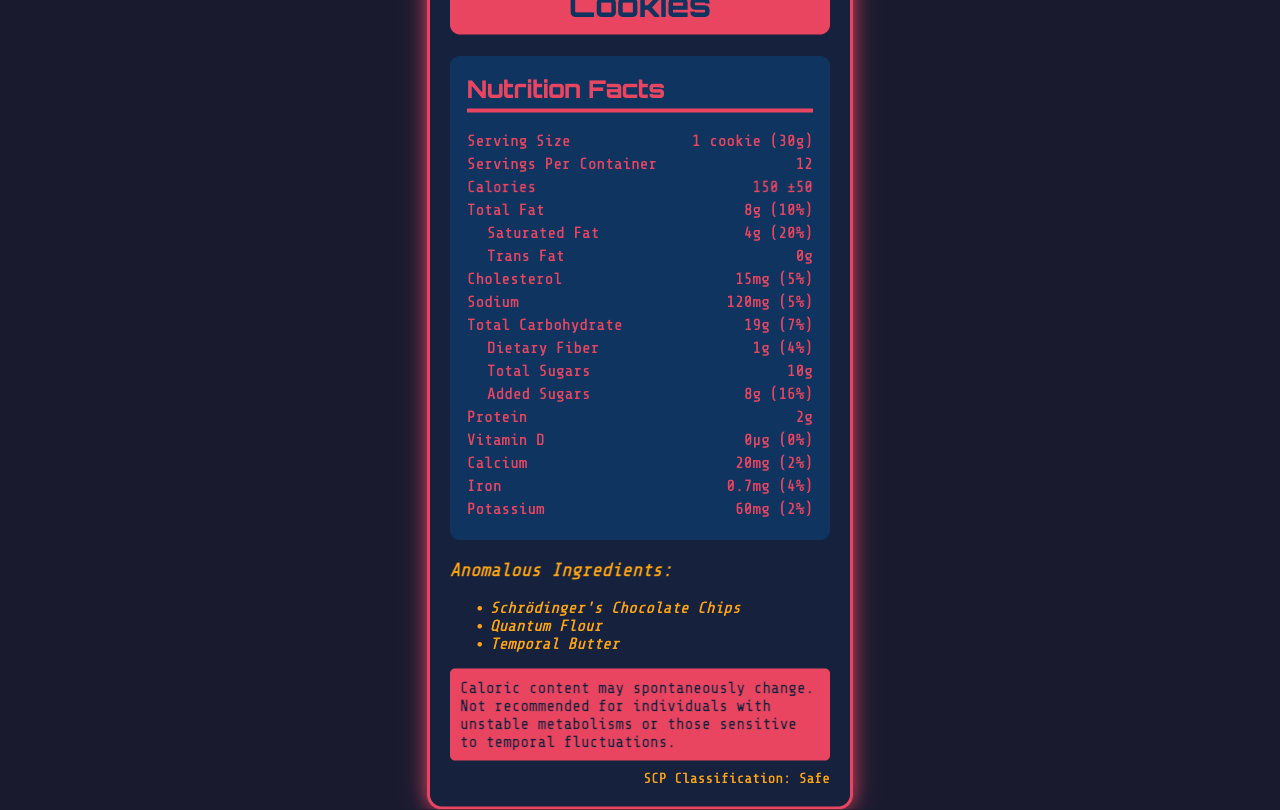What is the base calorie content of a Containment Cookie? The document lists the base calorie content as 150 calories per cookie.
Answer: 150 calories How large is the serving size for Containment Cookies? The serving size is specified as 1 cookie, which weighs 30 grams.
Answer: 1 cookie (30g) What is the daily value percentage for total fat in one Containment Cookie? The document shows that the total fat in one cookie contributes 10% to the daily value.
Answer: 10% Which ingredients are considered anomalous in the Containment Cookies? The document lists Schrödinger's Chocolate Chips, Quantum Flour, and Temporal Butter under anomalous ingredients.
Answer: Schrödinger's Chocolate Chips, Quantum Flour, Temporal Butter What is the SCP classification for Containment Cookies? The SCP classification is labeled as Safe in the document.
Answer: Safe How many milligrams of sodium are in a single Containment Cookie? The sodium content is listed as 120 milligrams per cookie.
Answer: 120 milligrams Which of the following statements is true about the vitamin D content in Containment Cookies? A. There is a high amount of vitamin D. B. The vitamin D content is zero. C. The vitamin D content fluctuates. D. It is not specified. The document specifies that the vitamin D content is 0 micrograms, which translates to a 0% daily value.
Answer: B What is the fluctuation range for the calorie content in Containment Cookies? A. ±20 B. ±30 C. ±50 D. ±70 The calorie content has a fluctuation range of ±50 as indicated in the document.
Answer: C True or False: Containment Cookies have 8 grams of trans fat. The document clearly states that trans fat content is 0 grams.
Answer: False Summarize the main idea of the document. The document offers a comprehensive breakdown of the nutritional content for Containment Cookies, including fluctuation risks, while highlighting its SCP classification and related game mechanics.
Answer: The document provides the nutritional facts and anomalies for Containment Cookies, detailing serving size, base calorie content, daily value percentages for various nutrients, and a warning about potential spontaneous changes in caloric content. The product also includes several anomalous ingredients and carries an SCP classification of Safe. Can you find out the reason behind the calorie fluctuations from the document? The document mentions the fluctuating calorie content but does not provide an explanation for why it fluctuates, only that it can spontaneously change.
Answer: Not enough information 